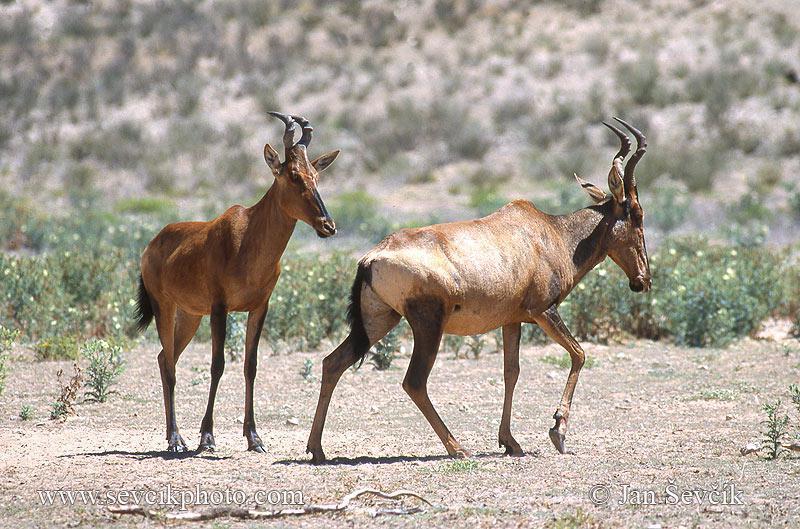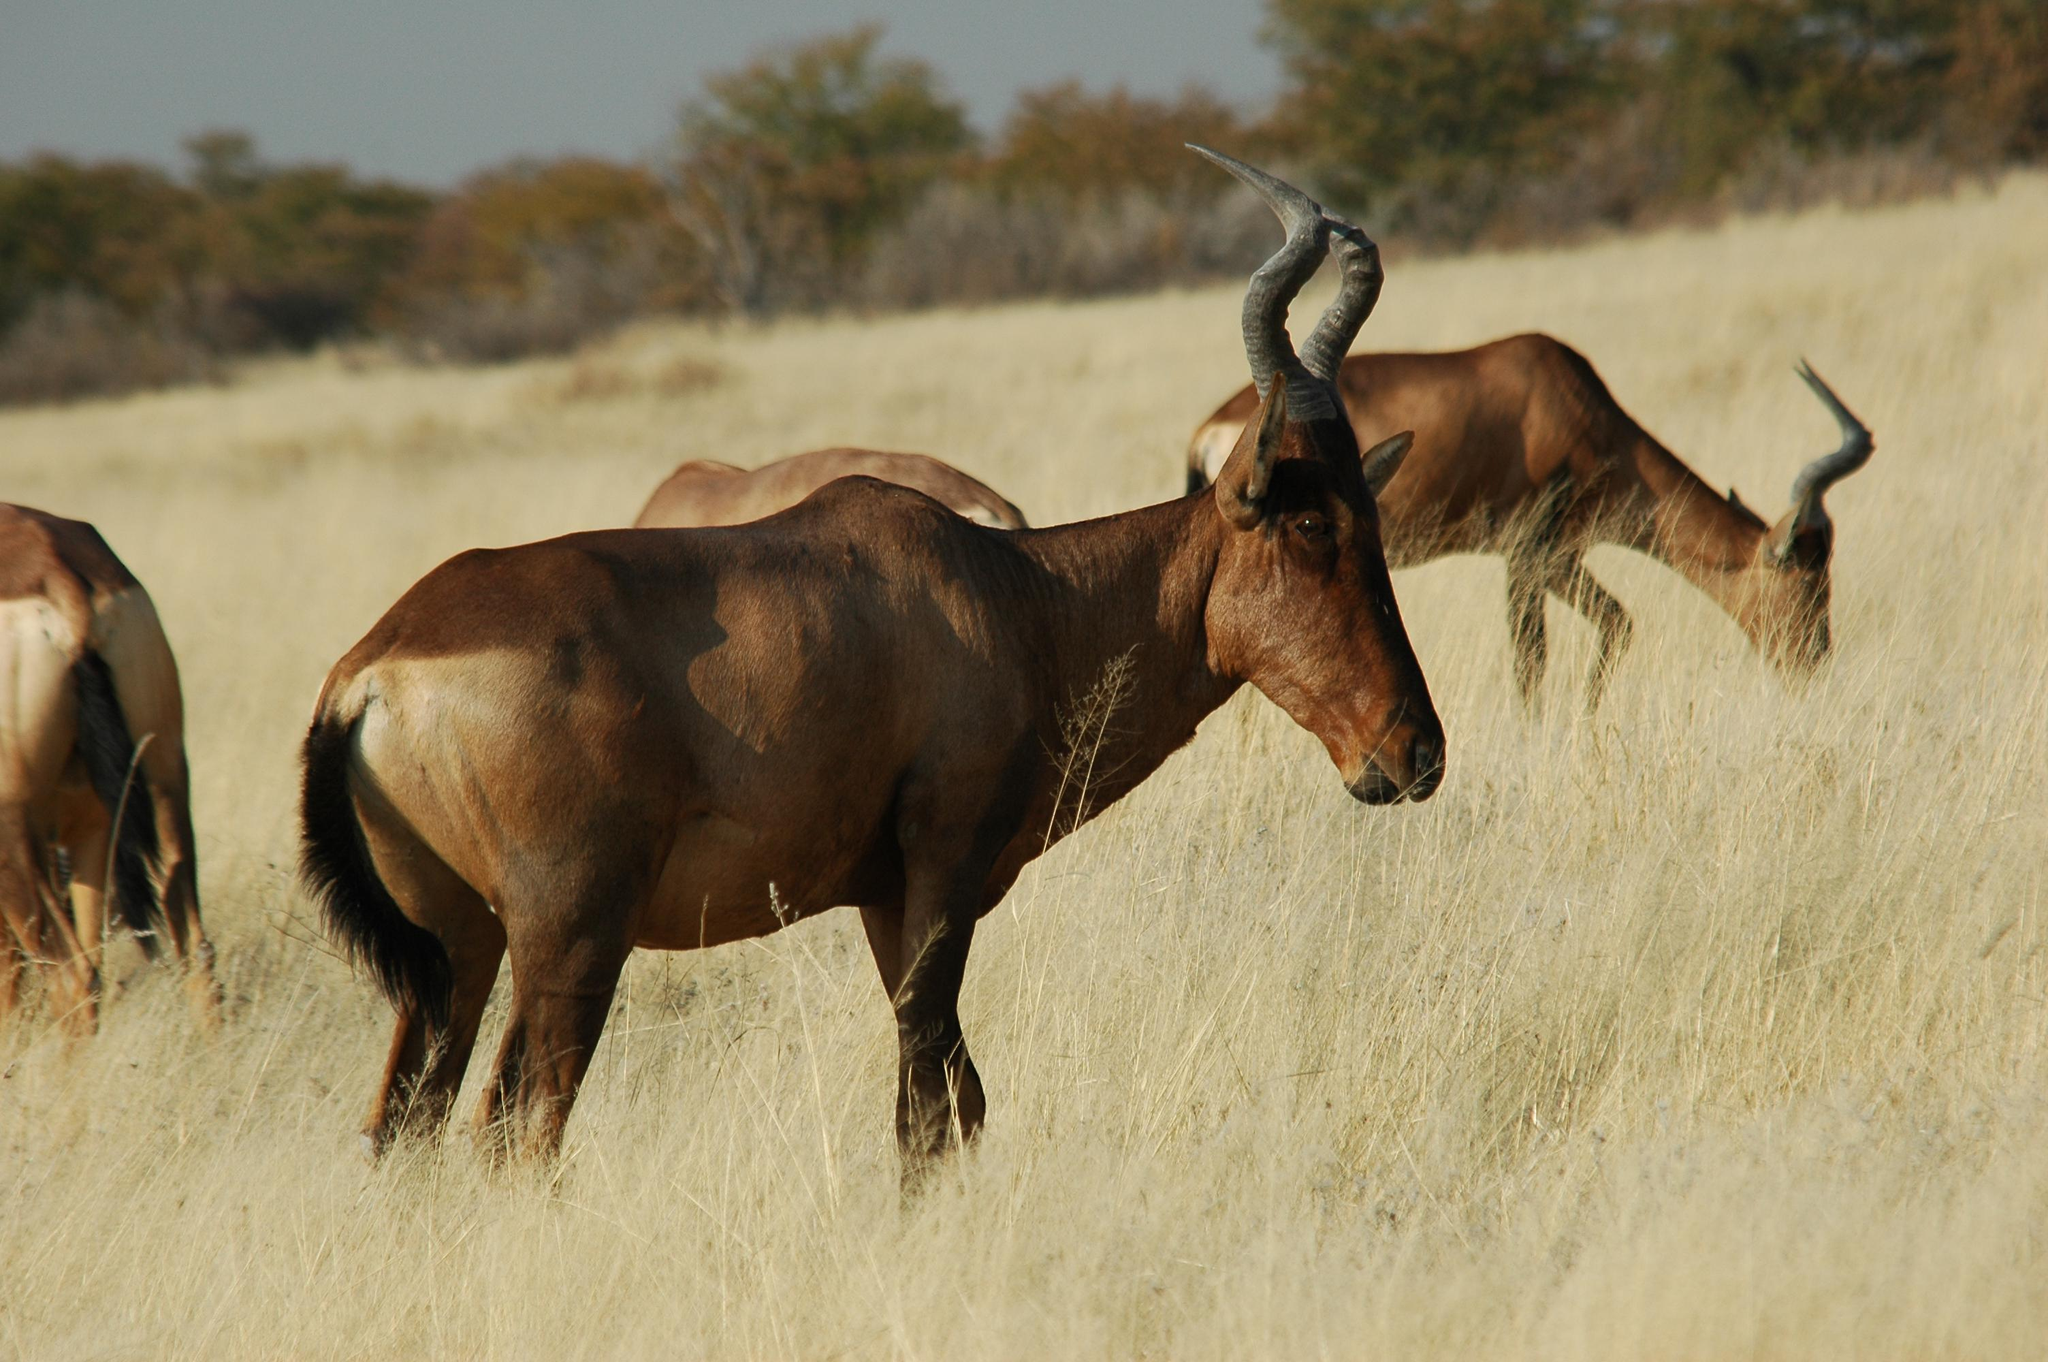The first image is the image on the left, the second image is the image on the right. Analyze the images presented: Is the assertion "The right image contains at least three hartebeest's." valid? Answer yes or no. Yes. The first image is the image on the left, the second image is the image on the right. Considering the images on both sides, is "All hooved animals in one image have both front legs off the ground." valid? Answer yes or no. No. 